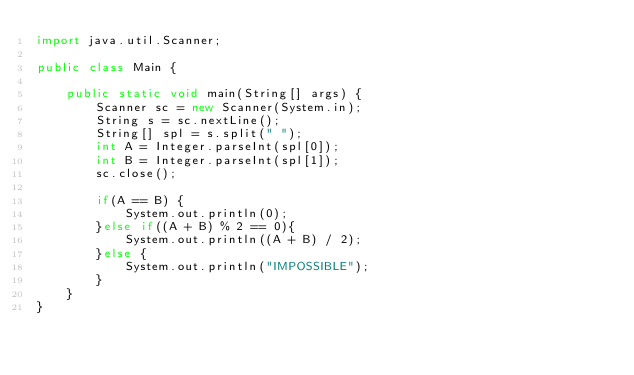Convert code to text. <code><loc_0><loc_0><loc_500><loc_500><_Java_>import java.util.Scanner;

public class Main {

	public static void main(String[] args) {
		Scanner sc = new Scanner(System.in);
		String s = sc.nextLine();
		String[] spl = s.split(" ");
		int A = Integer.parseInt(spl[0]);
		int B = Integer.parseInt(spl[1]);
		sc.close();

		if(A == B) {
			System.out.println(0);
		}else if((A + B) % 2 == 0){
			System.out.println((A + B) / 2);
		}else {
			System.out.println("IMPOSSIBLE");
		}
	}
}</code> 